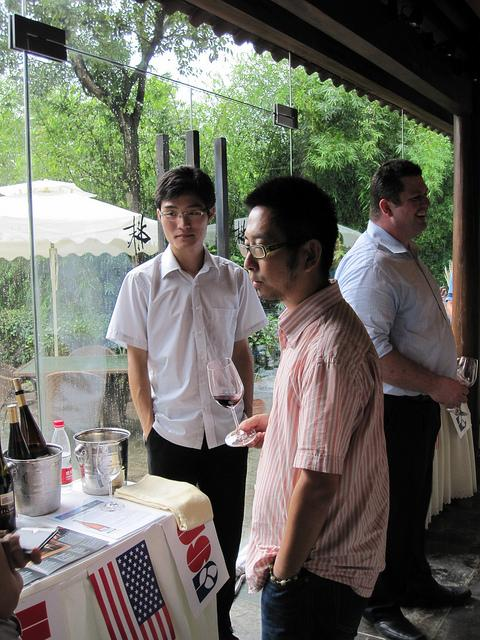What do two of the three men have on?

Choices:
A) glasses
B) tie
C) shirt
D) pants glasses 